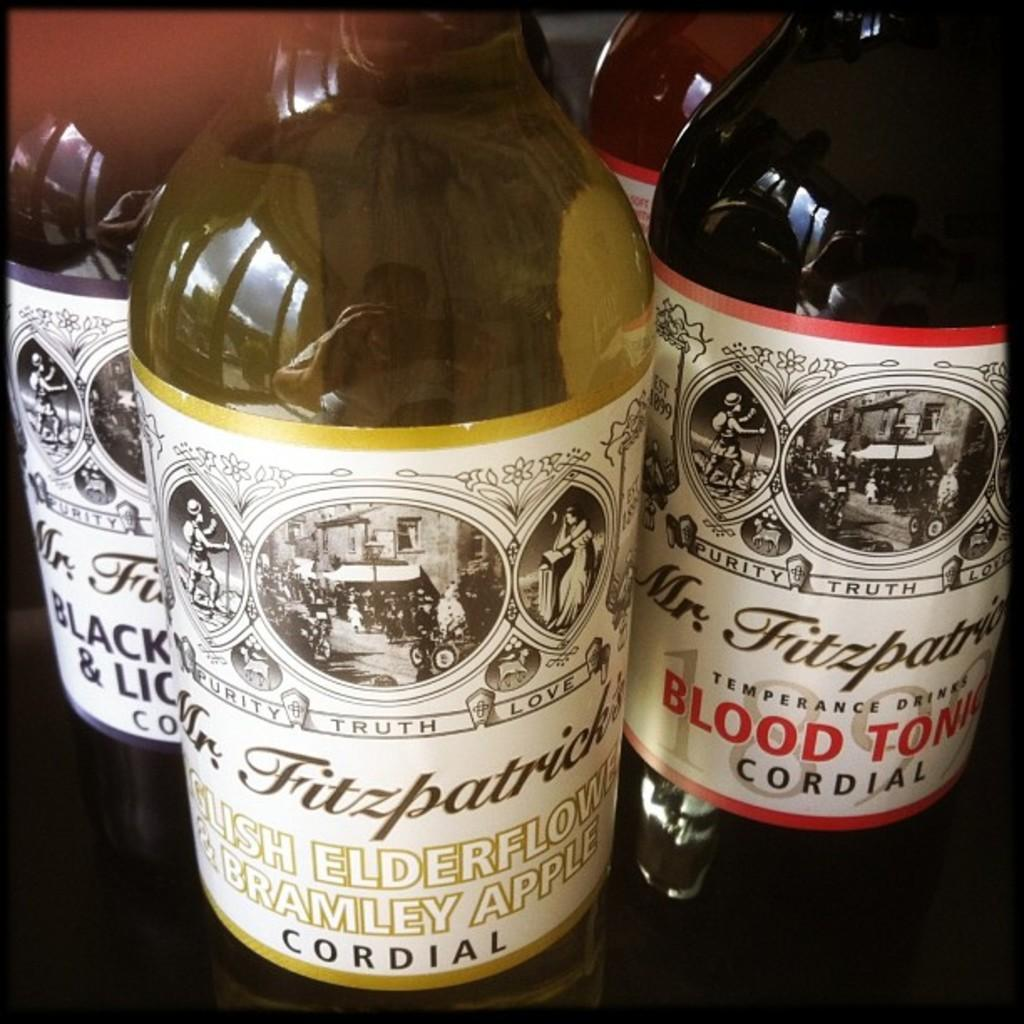<image>
Provide a brief description of the given image. Four bottles of Mr. Fitzpatrick's Cordial are being displayed next to each other. 